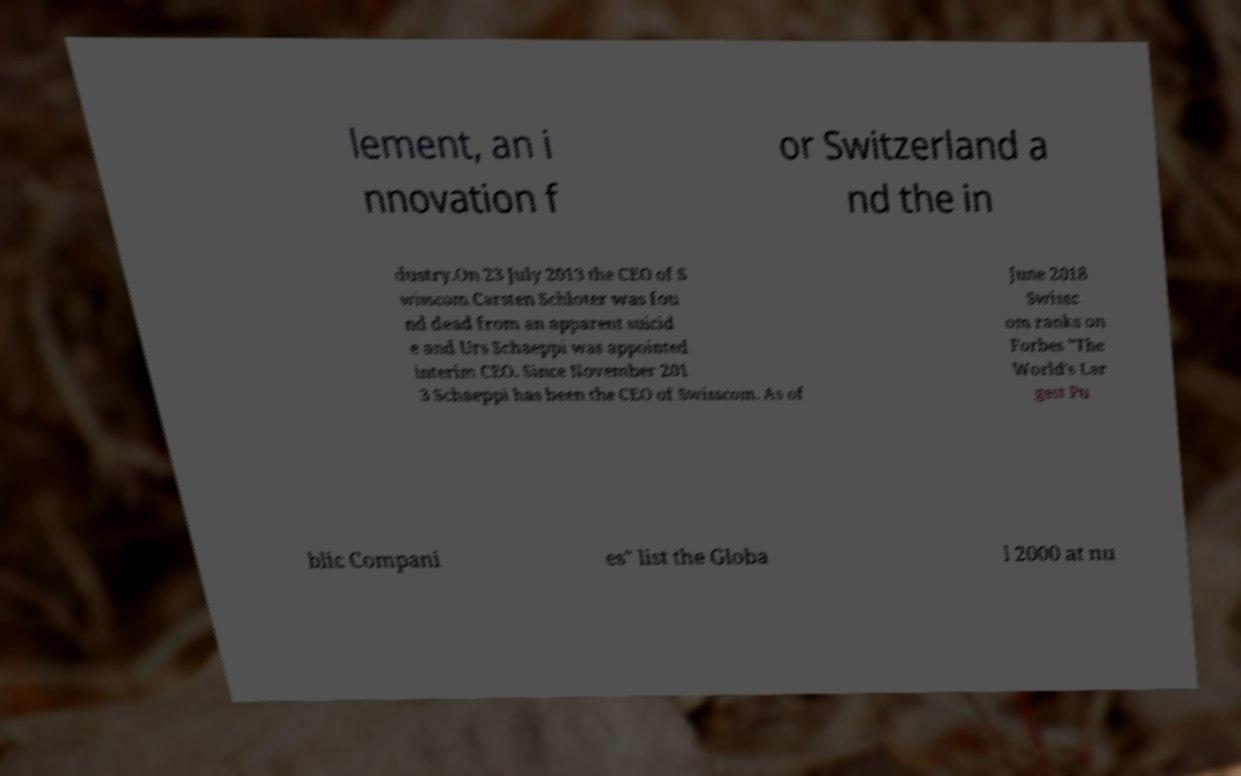I need the written content from this picture converted into text. Can you do that? lement, an i nnovation f or Switzerland a nd the in dustry.On 23 July 2013 the CEO of S wisscom Carsten Schloter was fou nd dead from an apparent suicid e and Urs Schaeppi was appointed interim CEO. Since November 201 3 Schaeppi has been the CEO of Swisscom. As of June 2018 Swissc om ranks on Forbes "The World's Lar gest Pu blic Compani es" list the Globa l 2000 at nu 